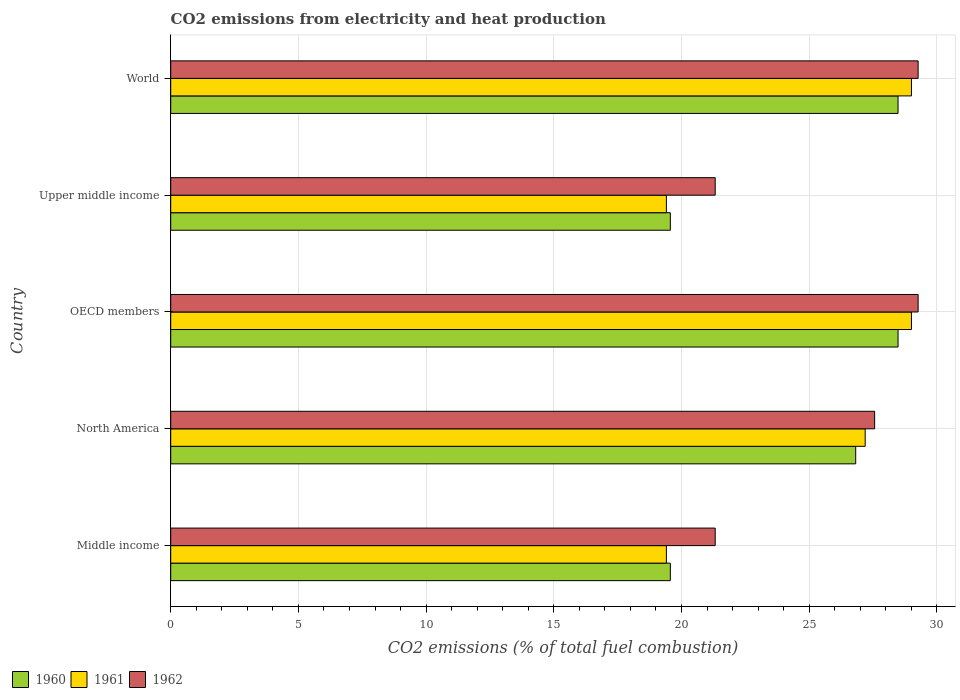How many different coloured bars are there?
Your answer should be very brief. 3. Are the number of bars on each tick of the Y-axis equal?
Ensure brevity in your answer.  Yes. In how many cases, is the number of bars for a given country not equal to the number of legend labels?
Ensure brevity in your answer.  0. What is the amount of CO2 emitted in 1962 in OECD members?
Your response must be concise. 29.26. Across all countries, what is the maximum amount of CO2 emitted in 1960?
Give a very brief answer. 28.48. Across all countries, what is the minimum amount of CO2 emitted in 1960?
Your answer should be compact. 19.56. What is the total amount of CO2 emitted in 1962 in the graph?
Your answer should be very brief. 128.73. What is the difference between the amount of CO2 emitted in 1962 in Middle income and that in OECD members?
Offer a terse response. -7.95. What is the difference between the amount of CO2 emitted in 1960 in Middle income and the amount of CO2 emitted in 1962 in Upper middle income?
Offer a very short reply. -1.76. What is the average amount of CO2 emitted in 1960 per country?
Offer a very short reply. 24.58. What is the difference between the amount of CO2 emitted in 1961 and amount of CO2 emitted in 1962 in Upper middle income?
Ensure brevity in your answer.  -1.91. In how many countries, is the amount of CO2 emitted in 1962 greater than 25 %?
Provide a short and direct response. 3. What is the ratio of the amount of CO2 emitted in 1961 in North America to that in Upper middle income?
Your answer should be compact. 1.4. What is the difference between the highest and the second highest amount of CO2 emitted in 1961?
Keep it short and to the point. 0. What is the difference between the highest and the lowest amount of CO2 emitted in 1960?
Ensure brevity in your answer.  8.92. Is the sum of the amount of CO2 emitted in 1960 in OECD members and World greater than the maximum amount of CO2 emitted in 1961 across all countries?
Offer a very short reply. Yes. What does the 2nd bar from the bottom in Middle income represents?
Offer a very short reply. 1961. Is it the case that in every country, the sum of the amount of CO2 emitted in 1960 and amount of CO2 emitted in 1962 is greater than the amount of CO2 emitted in 1961?
Make the answer very short. Yes. How many bars are there?
Offer a terse response. 15. Are all the bars in the graph horizontal?
Provide a short and direct response. Yes. How many countries are there in the graph?
Provide a succinct answer. 5. What is the difference between two consecutive major ticks on the X-axis?
Give a very brief answer. 5. Does the graph contain grids?
Offer a very short reply. Yes. Where does the legend appear in the graph?
Keep it short and to the point. Bottom left. How are the legend labels stacked?
Provide a succinct answer. Horizontal. What is the title of the graph?
Your response must be concise. CO2 emissions from electricity and heat production. Does "1979" appear as one of the legend labels in the graph?
Give a very brief answer. No. What is the label or title of the X-axis?
Provide a succinct answer. CO2 emissions (% of total fuel combustion). What is the CO2 emissions (% of total fuel combustion) in 1960 in Middle income?
Your response must be concise. 19.56. What is the CO2 emissions (% of total fuel combustion) in 1961 in Middle income?
Your answer should be very brief. 19.41. What is the CO2 emissions (% of total fuel combustion) of 1962 in Middle income?
Offer a very short reply. 21.32. What is the CO2 emissions (% of total fuel combustion) of 1960 in North America?
Your response must be concise. 26.82. What is the CO2 emissions (% of total fuel combustion) in 1961 in North America?
Your answer should be very brief. 27.19. What is the CO2 emissions (% of total fuel combustion) of 1962 in North America?
Offer a very short reply. 27.56. What is the CO2 emissions (% of total fuel combustion) in 1960 in OECD members?
Give a very brief answer. 28.48. What is the CO2 emissions (% of total fuel combustion) of 1961 in OECD members?
Provide a short and direct response. 29. What is the CO2 emissions (% of total fuel combustion) of 1962 in OECD members?
Offer a very short reply. 29.26. What is the CO2 emissions (% of total fuel combustion) in 1960 in Upper middle income?
Make the answer very short. 19.56. What is the CO2 emissions (% of total fuel combustion) of 1961 in Upper middle income?
Your answer should be very brief. 19.41. What is the CO2 emissions (% of total fuel combustion) in 1962 in Upper middle income?
Provide a succinct answer. 21.32. What is the CO2 emissions (% of total fuel combustion) of 1960 in World?
Give a very brief answer. 28.48. What is the CO2 emissions (% of total fuel combustion) in 1961 in World?
Your answer should be very brief. 29. What is the CO2 emissions (% of total fuel combustion) in 1962 in World?
Your answer should be very brief. 29.26. Across all countries, what is the maximum CO2 emissions (% of total fuel combustion) of 1960?
Offer a terse response. 28.48. Across all countries, what is the maximum CO2 emissions (% of total fuel combustion) of 1961?
Your answer should be compact. 29. Across all countries, what is the maximum CO2 emissions (% of total fuel combustion) in 1962?
Ensure brevity in your answer.  29.26. Across all countries, what is the minimum CO2 emissions (% of total fuel combustion) in 1960?
Offer a very short reply. 19.56. Across all countries, what is the minimum CO2 emissions (% of total fuel combustion) of 1961?
Provide a succinct answer. 19.41. Across all countries, what is the minimum CO2 emissions (% of total fuel combustion) of 1962?
Your answer should be very brief. 21.32. What is the total CO2 emissions (% of total fuel combustion) of 1960 in the graph?
Your response must be concise. 122.9. What is the total CO2 emissions (% of total fuel combustion) in 1961 in the graph?
Offer a terse response. 124.02. What is the total CO2 emissions (% of total fuel combustion) of 1962 in the graph?
Offer a terse response. 128.73. What is the difference between the CO2 emissions (% of total fuel combustion) in 1960 in Middle income and that in North America?
Provide a short and direct response. -7.26. What is the difference between the CO2 emissions (% of total fuel combustion) of 1961 in Middle income and that in North America?
Your response must be concise. -7.78. What is the difference between the CO2 emissions (% of total fuel combustion) in 1962 in Middle income and that in North America?
Keep it short and to the point. -6.24. What is the difference between the CO2 emissions (% of total fuel combustion) of 1960 in Middle income and that in OECD members?
Make the answer very short. -8.92. What is the difference between the CO2 emissions (% of total fuel combustion) of 1961 in Middle income and that in OECD members?
Offer a terse response. -9.6. What is the difference between the CO2 emissions (% of total fuel combustion) in 1962 in Middle income and that in OECD members?
Keep it short and to the point. -7.95. What is the difference between the CO2 emissions (% of total fuel combustion) in 1960 in Middle income and that in World?
Make the answer very short. -8.92. What is the difference between the CO2 emissions (% of total fuel combustion) in 1961 in Middle income and that in World?
Make the answer very short. -9.6. What is the difference between the CO2 emissions (% of total fuel combustion) in 1962 in Middle income and that in World?
Make the answer very short. -7.95. What is the difference between the CO2 emissions (% of total fuel combustion) in 1960 in North America and that in OECD members?
Make the answer very short. -1.66. What is the difference between the CO2 emissions (% of total fuel combustion) in 1961 in North America and that in OECD members?
Provide a succinct answer. -1.81. What is the difference between the CO2 emissions (% of total fuel combustion) in 1962 in North America and that in OECD members?
Give a very brief answer. -1.7. What is the difference between the CO2 emissions (% of total fuel combustion) of 1960 in North America and that in Upper middle income?
Your response must be concise. 7.26. What is the difference between the CO2 emissions (% of total fuel combustion) in 1961 in North America and that in Upper middle income?
Offer a very short reply. 7.78. What is the difference between the CO2 emissions (% of total fuel combustion) in 1962 in North America and that in Upper middle income?
Offer a very short reply. 6.24. What is the difference between the CO2 emissions (% of total fuel combustion) of 1960 in North America and that in World?
Give a very brief answer. -1.66. What is the difference between the CO2 emissions (% of total fuel combustion) in 1961 in North America and that in World?
Offer a very short reply. -1.81. What is the difference between the CO2 emissions (% of total fuel combustion) in 1962 in North America and that in World?
Offer a very short reply. -1.7. What is the difference between the CO2 emissions (% of total fuel combustion) in 1960 in OECD members and that in Upper middle income?
Offer a terse response. 8.92. What is the difference between the CO2 emissions (% of total fuel combustion) of 1961 in OECD members and that in Upper middle income?
Provide a short and direct response. 9.6. What is the difference between the CO2 emissions (% of total fuel combustion) of 1962 in OECD members and that in Upper middle income?
Provide a succinct answer. 7.95. What is the difference between the CO2 emissions (% of total fuel combustion) of 1962 in OECD members and that in World?
Your answer should be very brief. 0. What is the difference between the CO2 emissions (% of total fuel combustion) in 1960 in Upper middle income and that in World?
Your answer should be very brief. -8.92. What is the difference between the CO2 emissions (% of total fuel combustion) of 1961 in Upper middle income and that in World?
Ensure brevity in your answer.  -9.6. What is the difference between the CO2 emissions (% of total fuel combustion) in 1962 in Upper middle income and that in World?
Provide a succinct answer. -7.95. What is the difference between the CO2 emissions (% of total fuel combustion) in 1960 in Middle income and the CO2 emissions (% of total fuel combustion) in 1961 in North America?
Provide a succinct answer. -7.63. What is the difference between the CO2 emissions (% of total fuel combustion) in 1960 in Middle income and the CO2 emissions (% of total fuel combustion) in 1962 in North America?
Offer a very short reply. -8. What is the difference between the CO2 emissions (% of total fuel combustion) of 1961 in Middle income and the CO2 emissions (% of total fuel combustion) of 1962 in North America?
Give a very brief answer. -8.15. What is the difference between the CO2 emissions (% of total fuel combustion) in 1960 in Middle income and the CO2 emissions (% of total fuel combustion) in 1961 in OECD members?
Your answer should be very brief. -9.44. What is the difference between the CO2 emissions (% of total fuel combustion) in 1960 in Middle income and the CO2 emissions (% of total fuel combustion) in 1962 in OECD members?
Offer a terse response. -9.7. What is the difference between the CO2 emissions (% of total fuel combustion) of 1961 in Middle income and the CO2 emissions (% of total fuel combustion) of 1962 in OECD members?
Ensure brevity in your answer.  -9.86. What is the difference between the CO2 emissions (% of total fuel combustion) of 1960 in Middle income and the CO2 emissions (% of total fuel combustion) of 1961 in Upper middle income?
Keep it short and to the point. 0.15. What is the difference between the CO2 emissions (% of total fuel combustion) of 1960 in Middle income and the CO2 emissions (% of total fuel combustion) of 1962 in Upper middle income?
Provide a short and direct response. -1.76. What is the difference between the CO2 emissions (% of total fuel combustion) of 1961 in Middle income and the CO2 emissions (% of total fuel combustion) of 1962 in Upper middle income?
Your answer should be very brief. -1.91. What is the difference between the CO2 emissions (% of total fuel combustion) of 1960 in Middle income and the CO2 emissions (% of total fuel combustion) of 1961 in World?
Give a very brief answer. -9.44. What is the difference between the CO2 emissions (% of total fuel combustion) in 1960 in Middle income and the CO2 emissions (% of total fuel combustion) in 1962 in World?
Your answer should be very brief. -9.7. What is the difference between the CO2 emissions (% of total fuel combustion) in 1961 in Middle income and the CO2 emissions (% of total fuel combustion) in 1962 in World?
Keep it short and to the point. -9.86. What is the difference between the CO2 emissions (% of total fuel combustion) in 1960 in North America and the CO2 emissions (% of total fuel combustion) in 1961 in OECD members?
Give a very brief answer. -2.18. What is the difference between the CO2 emissions (% of total fuel combustion) of 1960 in North America and the CO2 emissions (% of total fuel combustion) of 1962 in OECD members?
Offer a terse response. -2.44. What is the difference between the CO2 emissions (% of total fuel combustion) in 1961 in North America and the CO2 emissions (% of total fuel combustion) in 1962 in OECD members?
Offer a terse response. -2.07. What is the difference between the CO2 emissions (% of total fuel combustion) of 1960 in North America and the CO2 emissions (% of total fuel combustion) of 1961 in Upper middle income?
Ensure brevity in your answer.  7.41. What is the difference between the CO2 emissions (% of total fuel combustion) in 1960 in North America and the CO2 emissions (% of total fuel combustion) in 1962 in Upper middle income?
Your answer should be compact. 5.5. What is the difference between the CO2 emissions (% of total fuel combustion) of 1961 in North America and the CO2 emissions (% of total fuel combustion) of 1962 in Upper middle income?
Give a very brief answer. 5.87. What is the difference between the CO2 emissions (% of total fuel combustion) in 1960 in North America and the CO2 emissions (% of total fuel combustion) in 1961 in World?
Keep it short and to the point. -2.18. What is the difference between the CO2 emissions (% of total fuel combustion) of 1960 in North America and the CO2 emissions (% of total fuel combustion) of 1962 in World?
Make the answer very short. -2.44. What is the difference between the CO2 emissions (% of total fuel combustion) of 1961 in North America and the CO2 emissions (% of total fuel combustion) of 1962 in World?
Make the answer very short. -2.07. What is the difference between the CO2 emissions (% of total fuel combustion) of 1960 in OECD members and the CO2 emissions (% of total fuel combustion) of 1961 in Upper middle income?
Give a very brief answer. 9.07. What is the difference between the CO2 emissions (% of total fuel combustion) in 1960 in OECD members and the CO2 emissions (% of total fuel combustion) in 1962 in Upper middle income?
Your answer should be very brief. 7.16. What is the difference between the CO2 emissions (% of total fuel combustion) of 1961 in OECD members and the CO2 emissions (% of total fuel combustion) of 1962 in Upper middle income?
Offer a terse response. 7.68. What is the difference between the CO2 emissions (% of total fuel combustion) in 1960 in OECD members and the CO2 emissions (% of total fuel combustion) in 1961 in World?
Your answer should be compact. -0.52. What is the difference between the CO2 emissions (% of total fuel combustion) in 1960 in OECD members and the CO2 emissions (% of total fuel combustion) in 1962 in World?
Ensure brevity in your answer.  -0.79. What is the difference between the CO2 emissions (% of total fuel combustion) in 1961 in OECD members and the CO2 emissions (% of total fuel combustion) in 1962 in World?
Your answer should be very brief. -0.26. What is the difference between the CO2 emissions (% of total fuel combustion) of 1960 in Upper middle income and the CO2 emissions (% of total fuel combustion) of 1961 in World?
Offer a terse response. -9.44. What is the difference between the CO2 emissions (% of total fuel combustion) of 1960 in Upper middle income and the CO2 emissions (% of total fuel combustion) of 1962 in World?
Make the answer very short. -9.7. What is the difference between the CO2 emissions (% of total fuel combustion) in 1961 in Upper middle income and the CO2 emissions (% of total fuel combustion) in 1962 in World?
Make the answer very short. -9.86. What is the average CO2 emissions (% of total fuel combustion) in 1960 per country?
Your answer should be compact. 24.58. What is the average CO2 emissions (% of total fuel combustion) of 1961 per country?
Give a very brief answer. 24.8. What is the average CO2 emissions (% of total fuel combustion) in 1962 per country?
Keep it short and to the point. 25.75. What is the difference between the CO2 emissions (% of total fuel combustion) of 1960 and CO2 emissions (% of total fuel combustion) of 1961 in Middle income?
Offer a very short reply. 0.15. What is the difference between the CO2 emissions (% of total fuel combustion) in 1960 and CO2 emissions (% of total fuel combustion) in 1962 in Middle income?
Make the answer very short. -1.76. What is the difference between the CO2 emissions (% of total fuel combustion) in 1961 and CO2 emissions (% of total fuel combustion) in 1962 in Middle income?
Offer a very short reply. -1.91. What is the difference between the CO2 emissions (% of total fuel combustion) of 1960 and CO2 emissions (% of total fuel combustion) of 1961 in North America?
Make the answer very short. -0.37. What is the difference between the CO2 emissions (% of total fuel combustion) in 1960 and CO2 emissions (% of total fuel combustion) in 1962 in North America?
Provide a succinct answer. -0.74. What is the difference between the CO2 emissions (% of total fuel combustion) of 1961 and CO2 emissions (% of total fuel combustion) of 1962 in North America?
Give a very brief answer. -0.37. What is the difference between the CO2 emissions (% of total fuel combustion) in 1960 and CO2 emissions (% of total fuel combustion) in 1961 in OECD members?
Make the answer very short. -0.52. What is the difference between the CO2 emissions (% of total fuel combustion) in 1960 and CO2 emissions (% of total fuel combustion) in 1962 in OECD members?
Ensure brevity in your answer.  -0.79. What is the difference between the CO2 emissions (% of total fuel combustion) in 1961 and CO2 emissions (% of total fuel combustion) in 1962 in OECD members?
Provide a succinct answer. -0.26. What is the difference between the CO2 emissions (% of total fuel combustion) in 1960 and CO2 emissions (% of total fuel combustion) in 1961 in Upper middle income?
Provide a short and direct response. 0.15. What is the difference between the CO2 emissions (% of total fuel combustion) in 1960 and CO2 emissions (% of total fuel combustion) in 1962 in Upper middle income?
Ensure brevity in your answer.  -1.76. What is the difference between the CO2 emissions (% of total fuel combustion) in 1961 and CO2 emissions (% of total fuel combustion) in 1962 in Upper middle income?
Your answer should be very brief. -1.91. What is the difference between the CO2 emissions (% of total fuel combustion) of 1960 and CO2 emissions (% of total fuel combustion) of 1961 in World?
Provide a short and direct response. -0.52. What is the difference between the CO2 emissions (% of total fuel combustion) in 1960 and CO2 emissions (% of total fuel combustion) in 1962 in World?
Give a very brief answer. -0.79. What is the difference between the CO2 emissions (% of total fuel combustion) of 1961 and CO2 emissions (% of total fuel combustion) of 1962 in World?
Give a very brief answer. -0.26. What is the ratio of the CO2 emissions (% of total fuel combustion) in 1960 in Middle income to that in North America?
Your response must be concise. 0.73. What is the ratio of the CO2 emissions (% of total fuel combustion) in 1961 in Middle income to that in North America?
Your answer should be compact. 0.71. What is the ratio of the CO2 emissions (% of total fuel combustion) in 1962 in Middle income to that in North America?
Ensure brevity in your answer.  0.77. What is the ratio of the CO2 emissions (% of total fuel combustion) in 1960 in Middle income to that in OECD members?
Give a very brief answer. 0.69. What is the ratio of the CO2 emissions (% of total fuel combustion) of 1961 in Middle income to that in OECD members?
Make the answer very short. 0.67. What is the ratio of the CO2 emissions (% of total fuel combustion) of 1962 in Middle income to that in OECD members?
Offer a very short reply. 0.73. What is the ratio of the CO2 emissions (% of total fuel combustion) of 1960 in Middle income to that in World?
Provide a short and direct response. 0.69. What is the ratio of the CO2 emissions (% of total fuel combustion) of 1961 in Middle income to that in World?
Your answer should be very brief. 0.67. What is the ratio of the CO2 emissions (% of total fuel combustion) in 1962 in Middle income to that in World?
Offer a very short reply. 0.73. What is the ratio of the CO2 emissions (% of total fuel combustion) of 1960 in North America to that in OECD members?
Provide a succinct answer. 0.94. What is the ratio of the CO2 emissions (% of total fuel combustion) in 1962 in North America to that in OECD members?
Provide a short and direct response. 0.94. What is the ratio of the CO2 emissions (% of total fuel combustion) of 1960 in North America to that in Upper middle income?
Your response must be concise. 1.37. What is the ratio of the CO2 emissions (% of total fuel combustion) in 1961 in North America to that in Upper middle income?
Your response must be concise. 1.4. What is the ratio of the CO2 emissions (% of total fuel combustion) of 1962 in North America to that in Upper middle income?
Your response must be concise. 1.29. What is the ratio of the CO2 emissions (% of total fuel combustion) in 1960 in North America to that in World?
Ensure brevity in your answer.  0.94. What is the ratio of the CO2 emissions (% of total fuel combustion) of 1962 in North America to that in World?
Provide a succinct answer. 0.94. What is the ratio of the CO2 emissions (% of total fuel combustion) of 1960 in OECD members to that in Upper middle income?
Offer a terse response. 1.46. What is the ratio of the CO2 emissions (% of total fuel combustion) in 1961 in OECD members to that in Upper middle income?
Provide a short and direct response. 1.49. What is the ratio of the CO2 emissions (% of total fuel combustion) of 1962 in OECD members to that in Upper middle income?
Offer a terse response. 1.37. What is the ratio of the CO2 emissions (% of total fuel combustion) in 1960 in Upper middle income to that in World?
Your response must be concise. 0.69. What is the ratio of the CO2 emissions (% of total fuel combustion) in 1961 in Upper middle income to that in World?
Provide a succinct answer. 0.67. What is the ratio of the CO2 emissions (% of total fuel combustion) in 1962 in Upper middle income to that in World?
Offer a terse response. 0.73. What is the difference between the highest and the second highest CO2 emissions (% of total fuel combustion) of 1961?
Provide a succinct answer. 0. What is the difference between the highest and the lowest CO2 emissions (% of total fuel combustion) of 1960?
Provide a short and direct response. 8.92. What is the difference between the highest and the lowest CO2 emissions (% of total fuel combustion) of 1961?
Offer a very short reply. 9.6. What is the difference between the highest and the lowest CO2 emissions (% of total fuel combustion) in 1962?
Offer a very short reply. 7.95. 